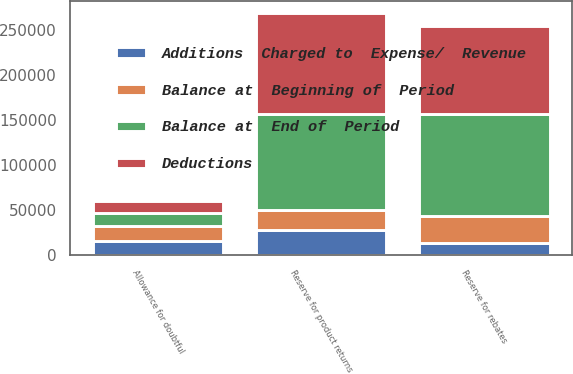Convert chart. <chart><loc_0><loc_0><loc_500><loc_500><stacked_bar_chart><ecel><fcel>Allowance for doubtful<fcel>Reserve for product returns<fcel>Reserve for rebates<nl><fcel>Additions  Charged to  Expense/  Revenue<fcel>15636<fcel>27910<fcel>13408<nl><fcel>Balance at  End of  Period<fcel>14595<fcel>106864<fcel>114176<nl><fcel>Deductions<fcel>13946<fcel>112842<fcel>97632<nl><fcel>Balance at  Beginning of  Period<fcel>16285<fcel>21932<fcel>29952<nl></chart> 